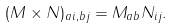<formula> <loc_0><loc_0><loc_500><loc_500>( M \times N ) _ { a i , b j } = M _ { a b } N _ { i j } .</formula> 